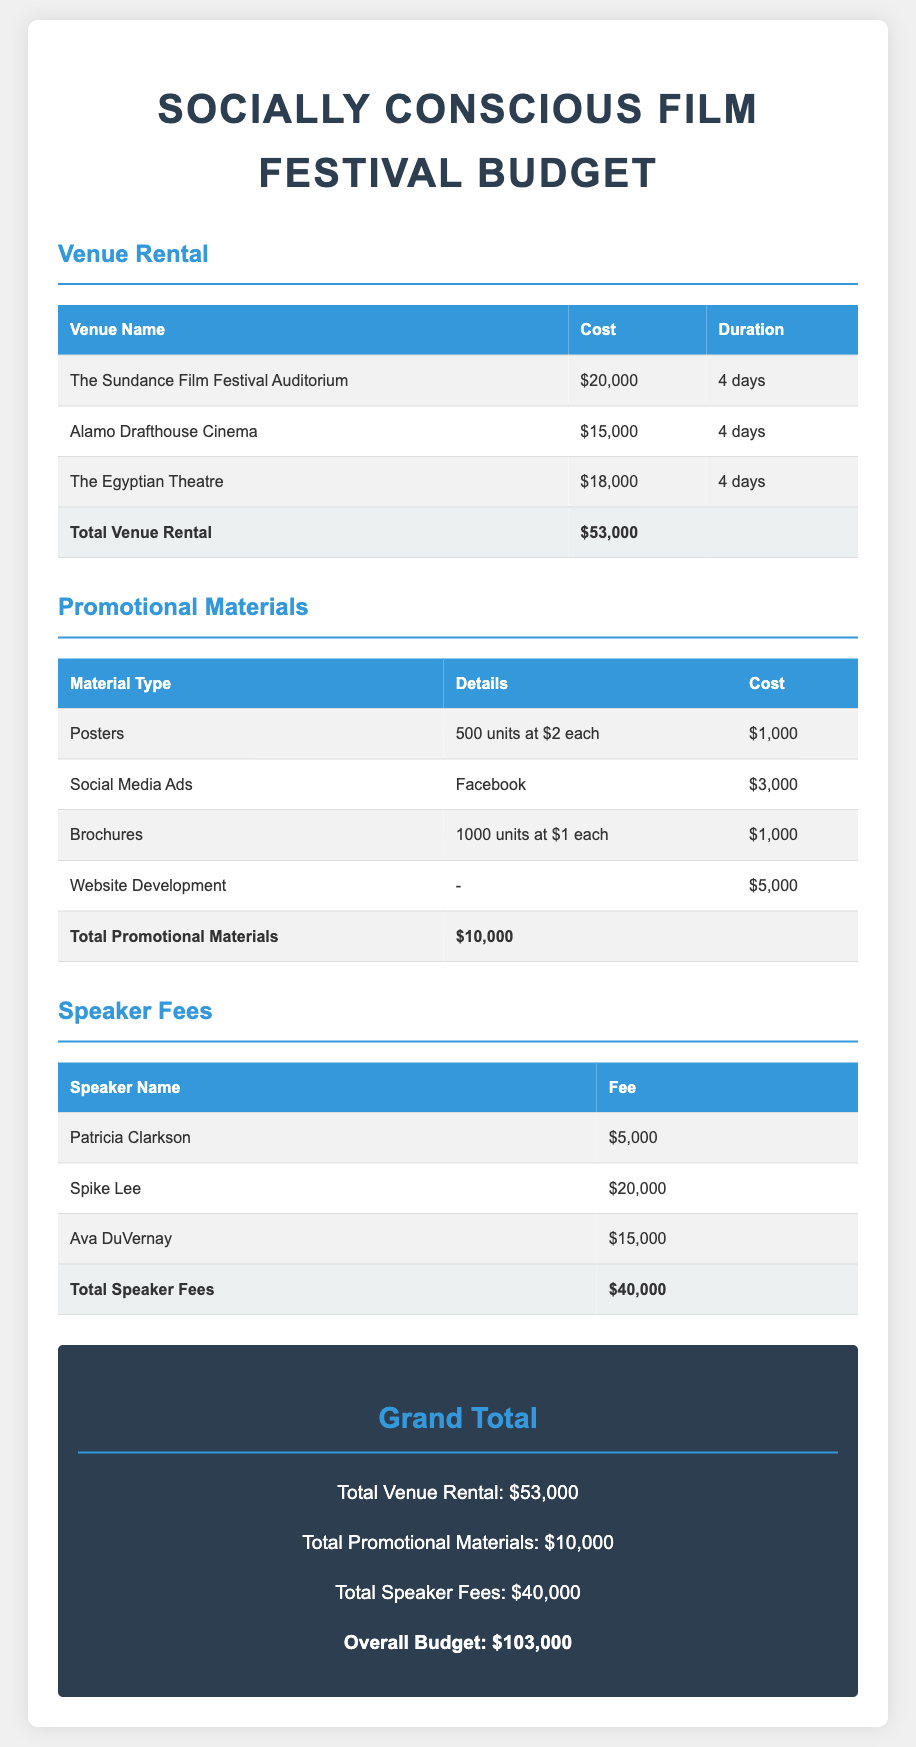What is the total cost for venue rental? The total cost for venue rental is provided at the bottom of the venue section, summing the costs of all listed venues.
Answer: $53,000 How many days is the venue rental for? The document states that the duration for each venue rental is 4 days.
Answer: 4 days What is the cost of social media ads? The cost for social media ads is specifically listed in the promotional materials section of the document.
Answer: $3,000 Who is the speaker with the highest fee? The document lists the fees for each speaker, indicating which one has the highest fee.
Answer: Spike Lee What is the total cost for promotional materials? The total cost for promotional materials is summarized in the promotional materials section.
Answer: $10,000 How many brochures are being produced? The number of brochures is detailed in the promotional materials table under the brochure entry.
Answer: 1000 units What is the grand total for the festival budget? The grand total is calculated and presented at the bottom of the document, combining all sections' totals.
Answer: $103,000 What is the fee for Patricia Clarkson? The fee for Patricia Clarkson is explicitly stated in the speaker fees table.
Answer: $5,000 What type of venue is The Sundance Film Festival Auditorium? The document specifies the venue names and their associated costs, indicating that it is an auditorium.
Answer: Auditorium 